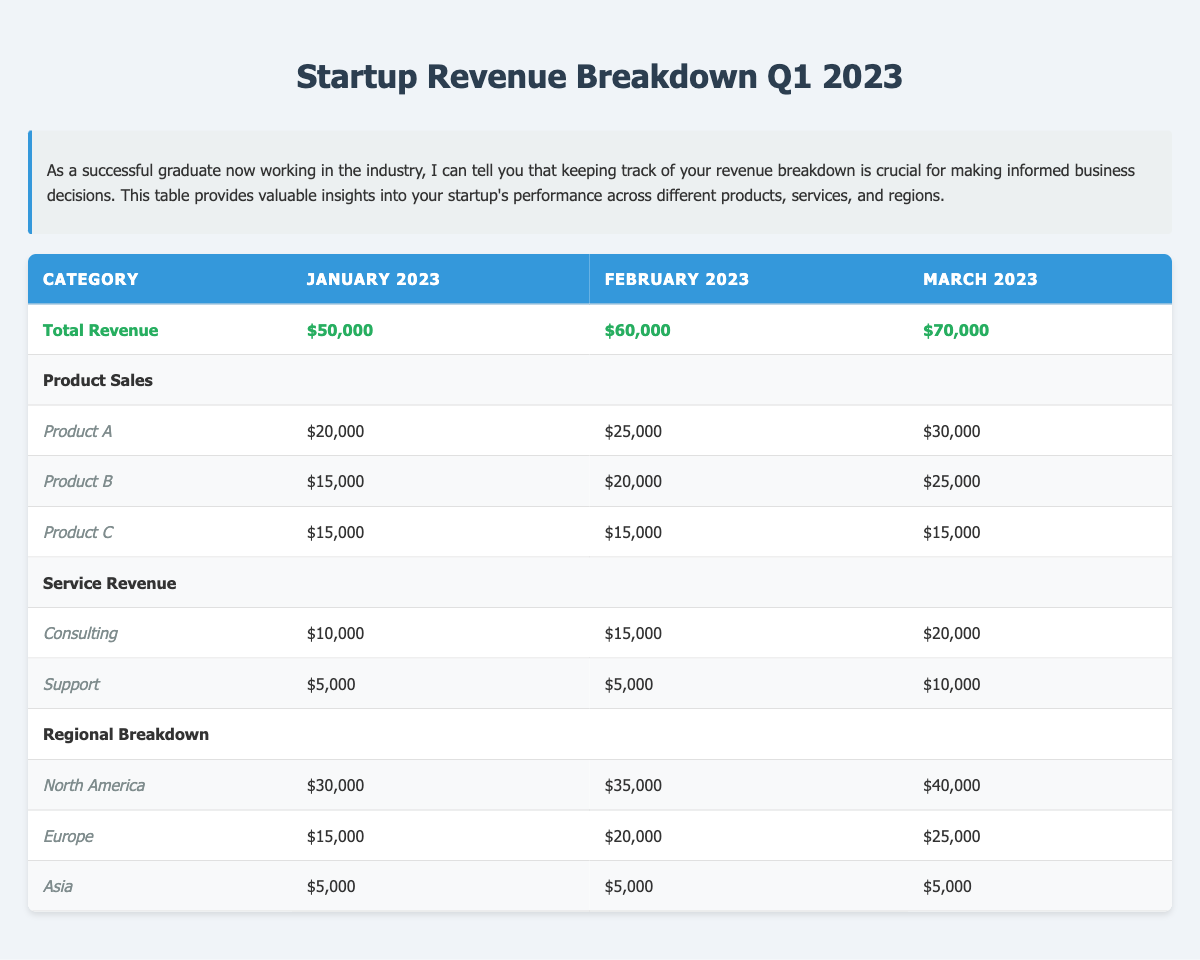What was the total revenue for March 2023? Referring to the table, the total revenue for March 2023 is listed under the Total Revenue row, which shows $70,000.
Answer: $70,000 Which product sold the most in February 2023? By looking at the Product Sales for February 2023, Product A has the highest sales at $25,000, compared to Product B at $20,000 and Product C at $15,000.
Answer: Product A What is the combined revenue from consulting services over the three months? Adding the Consulting revenue for January ($10,000), February ($15,000), and March ($20,000) gives a total of $10,000 + $15,000 + $20,000 = $45,000.
Answer: $45,000 Did the revenue from Asia change throughout the three months? The revenue from Asia remained constant at $5,000 for all three months, so there was no change.
Answer: No What is the average total revenue over Q1 2023? The total revenue for the three months is $50,000 (January) + $60,000 (February) + $70,000 (March) = $180,000. To find the average, we divide by 3: $180,000 / 3 = $60,000.
Answer: $60,000 How much more revenue did North America generate compared to Europe in February 2023? In February 2023, North America generated $35,000, while Europe generated $20,000. The difference is $35,000 - $20,000 = $15,000.
Answer: $15,000 Which region had the least revenue in March 2023? The table shows that Asia had the least revenue at $5,000 for March 2023 compared to North America ($40,000) and Europe ($25,000).
Answer: Asia What percentage of the total revenue in January 2023 came from product sales? In January 2023, the total revenue is $50,000, and product sales total $20,000 + $15,000 + $15,000 = $50,000. The percentage is ($50,000 / $50,000) * 100 = 100%.
Answer: 100% Did the consulting revenue increase every month in Q1 2023? Consulting revenue was $10,000 in January, $15,000 in February, and $20,000 in March, which shows an increase each month.
Answer: Yes What is the total revenue from Product C over the three months? Product C sales were $15,000 in January, $15,000 in February, and $15,000 in March, totaling $15,000 + $15,000 + $15,000 = $45,000.
Answer: $45,000 